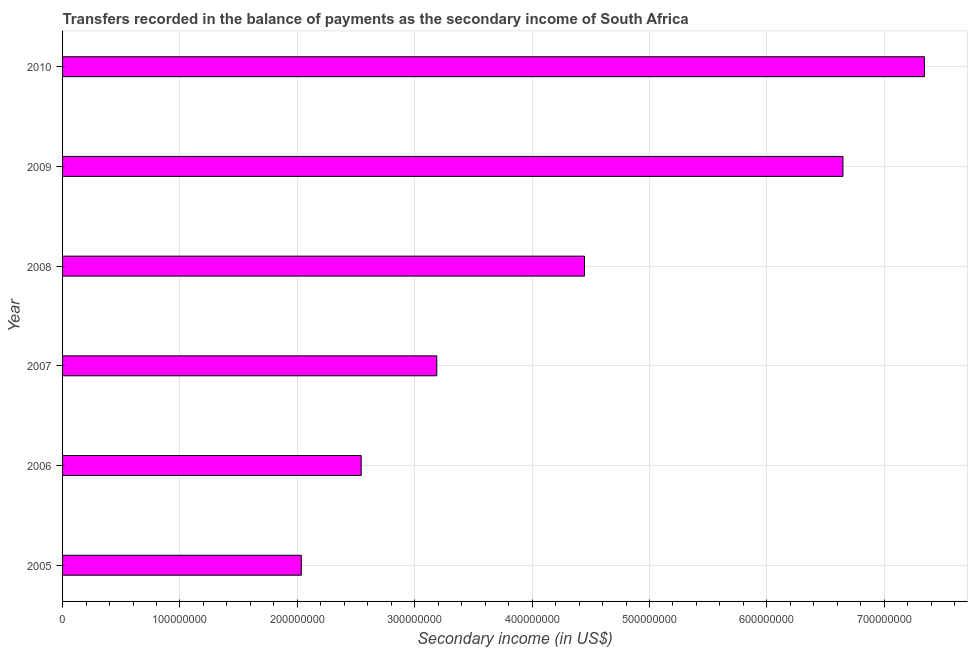What is the title of the graph?
Your answer should be very brief. Transfers recorded in the balance of payments as the secondary income of South Africa. What is the label or title of the X-axis?
Your response must be concise. Secondary income (in US$). What is the amount of secondary income in 2005?
Offer a very short reply. 2.03e+08. Across all years, what is the maximum amount of secondary income?
Give a very brief answer. 7.34e+08. Across all years, what is the minimum amount of secondary income?
Provide a short and direct response. 2.03e+08. In which year was the amount of secondary income minimum?
Make the answer very short. 2005. What is the sum of the amount of secondary income?
Your answer should be very brief. 2.62e+09. What is the difference between the amount of secondary income in 2005 and 2009?
Give a very brief answer. -4.61e+08. What is the average amount of secondary income per year?
Give a very brief answer. 4.37e+08. What is the median amount of secondary income?
Your answer should be compact. 3.82e+08. In how many years, is the amount of secondary income greater than 460000000 US$?
Your answer should be compact. 2. What is the ratio of the amount of secondary income in 2007 to that in 2009?
Keep it short and to the point. 0.48. Is the difference between the amount of secondary income in 2005 and 2007 greater than the difference between any two years?
Your answer should be very brief. No. What is the difference between the highest and the second highest amount of secondary income?
Provide a short and direct response. 6.94e+07. Is the sum of the amount of secondary income in 2006 and 2008 greater than the maximum amount of secondary income across all years?
Offer a terse response. No. What is the difference between the highest and the lowest amount of secondary income?
Your answer should be compact. 5.31e+08. In how many years, is the amount of secondary income greater than the average amount of secondary income taken over all years?
Offer a terse response. 3. How many bars are there?
Give a very brief answer. 6. Are all the bars in the graph horizontal?
Keep it short and to the point. Yes. How many years are there in the graph?
Provide a succinct answer. 6. What is the Secondary income (in US$) in 2005?
Make the answer very short. 2.03e+08. What is the Secondary income (in US$) in 2006?
Ensure brevity in your answer.  2.54e+08. What is the Secondary income (in US$) of 2007?
Make the answer very short. 3.19e+08. What is the Secondary income (in US$) of 2008?
Make the answer very short. 4.45e+08. What is the Secondary income (in US$) of 2009?
Provide a short and direct response. 6.65e+08. What is the Secondary income (in US$) of 2010?
Your response must be concise. 7.34e+08. What is the difference between the Secondary income (in US$) in 2005 and 2006?
Give a very brief answer. -5.10e+07. What is the difference between the Secondary income (in US$) in 2005 and 2007?
Offer a terse response. -1.15e+08. What is the difference between the Secondary income (in US$) in 2005 and 2008?
Your response must be concise. -2.41e+08. What is the difference between the Secondary income (in US$) in 2005 and 2009?
Keep it short and to the point. -4.61e+08. What is the difference between the Secondary income (in US$) in 2005 and 2010?
Your answer should be compact. -5.31e+08. What is the difference between the Secondary income (in US$) in 2006 and 2007?
Provide a succinct answer. -6.44e+07. What is the difference between the Secondary income (in US$) in 2006 and 2008?
Provide a succinct answer. -1.90e+08. What is the difference between the Secondary income (in US$) in 2006 and 2009?
Ensure brevity in your answer.  -4.10e+08. What is the difference between the Secondary income (in US$) in 2006 and 2010?
Make the answer very short. -4.80e+08. What is the difference between the Secondary income (in US$) in 2007 and 2008?
Your answer should be very brief. -1.26e+08. What is the difference between the Secondary income (in US$) in 2007 and 2009?
Provide a succinct answer. -3.46e+08. What is the difference between the Secondary income (in US$) in 2007 and 2010?
Your answer should be compact. -4.15e+08. What is the difference between the Secondary income (in US$) in 2008 and 2009?
Give a very brief answer. -2.20e+08. What is the difference between the Secondary income (in US$) in 2008 and 2010?
Your answer should be very brief. -2.90e+08. What is the difference between the Secondary income (in US$) in 2009 and 2010?
Offer a terse response. -6.94e+07. What is the ratio of the Secondary income (in US$) in 2005 to that in 2006?
Provide a succinct answer. 0.8. What is the ratio of the Secondary income (in US$) in 2005 to that in 2007?
Provide a succinct answer. 0.64. What is the ratio of the Secondary income (in US$) in 2005 to that in 2008?
Your response must be concise. 0.46. What is the ratio of the Secondary income (in US$) in 2005 to that in 2009?
Keep it short and to the point. 0.31. What is the ratio of the Secondary income (in US$) in 2005 to that in 2010?
Your answer should be compact. 0.28. What is the ratio of the Secondary income (in US$) in 2006 to that in 2007?
Keep it short and to the point. 0.8. What is the ratio of the Secondary income (in US$) in 2006 to that in 2008?
Make the answer very short. 0.57. What is the ratio of the Secondary income (in US$) in 2006 to that in 2009?
Provide a short and direct response. 0.38. What is the ratio of the Secondary income (in US$) in 2006 to that in 2010?
Provide a short and direct response. 0.35. What is the ratio of the Secondary income (in US$) in 2007 to that in 2008?
Offer a very short reply. 0.72. What is the ratio of the Secondary income (in US$) in 2007 to that in 2009?
Your answer should be compact. 0.48. What is the ratio of the Secondary income (in US$) in 2007 to that in 2010?
Keep it short and to the point. 0.43. What is the ratio of the Secondary income (in US$) in 2008 to that in 2009?
Offer a terse response. 0.67. What is the ratio of the Secondary income (in US$) in 2008 to that in 2010?
Provide a succinct answer. 0.61. What is the ratio of the Secondary income (in US$) in 2009 to that in 2010?
Your answer should be compact. 0.91. 